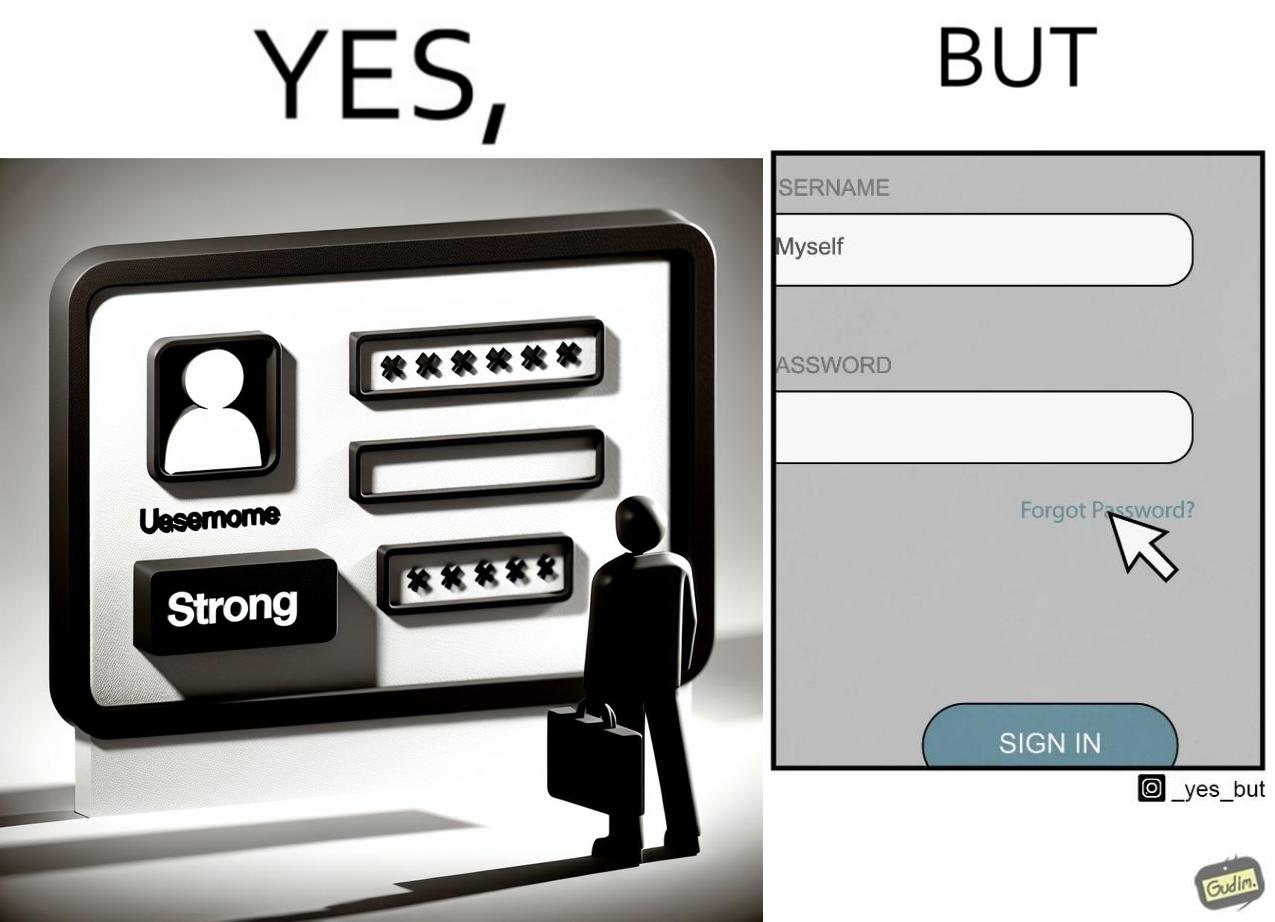Compare the left and right sides of this image. In the left part of the image: a screenshot of an account creation page of some site with login details filled in such as username and create password and password strength checker showing password as "strong" In the right part of the image: a screenshot of a login page of some site with username filled in and the user about to click on "Forget Password" link as the pointer is over the link 